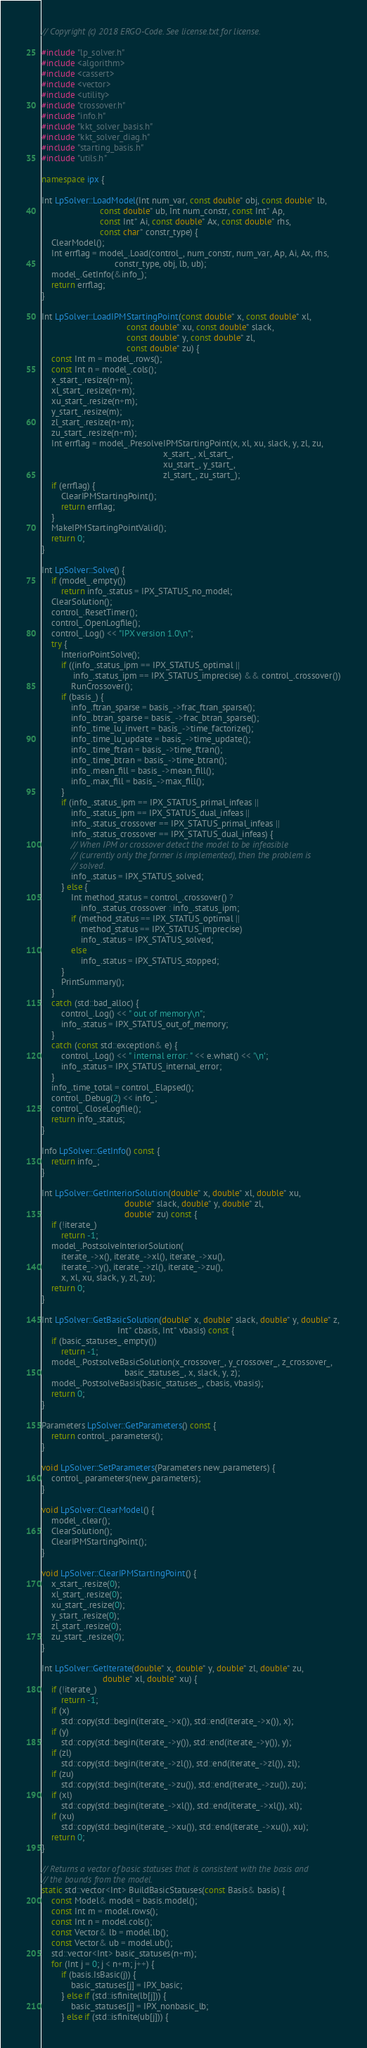<code> <loc_0><loc_0><loc_500><loc_500><_C++_>// Copyright (c) 2018 ERGO-Code. See license.txt for license.

#include "lp_solver.h"
#include <algorithm>
#include <cassert>
#include <vector>
#include <utility>
#include "crossover.h"
#include "info.h"
#include "kkt_solver_basis.h"
#include "kkt_solver_diag.h"
#include "starting_basis.h"
#include "utils.h"

namespace ipx {

Int LpSolver::LoadModel(Int num_var, const double* obj, const double* lb,
                        const double* ub, Int num_constr, const Int* Ap,
                        const Int* Ai, const double* Ax, const double* rhs,
                        const char* constr_type) {
    ClearModel();
    Int errflag = model_.Load(control_, num_constr, num_var, Ap, Ai, Ax, rhs,
                              constr_type, obj, lb, ub);
    model_.GetInfo(&info_);
    return errflag;
}

Int LpSolver::LoadIPMStartingPoint(const double* x, const double* xl,
                                   const double* xu, const double* slack,
                                   const double* y, const double* zl,
                                   const double* zu) {
    const Int m = model_.rows();
    const Int n = model_.cols();
    x_start_.resize(n+m);
    xl_start_.resize(n+m);
    xu_start_.resize(n+m);
    y_start_.resize(m);
    zl_start_.resize(n+m);
    zu_start_.resize(n+m);
    Int errflag = model_.PresolveIPMStartingPoint(x, xl, xu, slack, y, zl, zu,
                                                  x_start_, xl_start_,
                                                  xu_start_, y_start_,
                                                  zl_start_, zu_start_);
    if (errflag) {
        ClearIPMStartingPoint();
        return errflag;
    }
    MakeIPMStartingPointValid();
    return 0;
}

Int LpSolver::Solve() {
    if (model_.empty())
        return info_.status = IPX_STATUS_no_model;
    ClearSolution();
    control_.ResetTimer();
    control_.OpenLogfile();
    control_.Log() << "IPX version 1.0\n";
    try {
        InteriorPointSolve();
        if ((info_.status_ipm == IPX_STATUS_optimal ||
             info_.status_ipm == IPX_STATUS_imprecise) && control_.crossover())
            RunCrossover();
        if (basis_) {
            info_.ftran_sparse = basis_->frac_ftran_sparse();
            info_.btran_sparse = basis_->frac_btran_sparse();
            info_.time_lu_invert = basis_->time_factorize();
            info_.time_lu_update = basis_->time_update();
            info_.time_ftran = basis_->time_ftran();
            info_.time_btran = basis_->time_btran();
            info_.mean_fill = basis_->mean_fill();
            info_.max_fill = basis_->max_fill();
        }
        if (info_.status_ipm == IPX_STATUS_primal_infeas ||
            info_.status_ipm == IPX_STATUS_dual_infeas ||
            info_.status_crossover == IPX_STATUS_primal_infeas ||
            info_.status_crossover == IPX_STATUS_dual_infeas) {
            // When IPM or crossover detect the model to be infeasible
            // (currently only the former is implemented), then the problem is
            // solved.
            info_.status = IPX_STATUS_solved;
        } else {
            Int method_status = control_.crossover() ?
                info_.status_crossover : info_.status_ipm;
            if (method_status == IPX_STATUS_optimal ||
                method_status == IPX_STATUS_imprecise)
                info_.status = IPX_STATUS_solved;
            else
                info_.status = IPX_STATUS_stopped;
        }
        PrintSummary();
    }
    catch (std::bad_alloc) {
        control_.Log() << " out of memory\n";
        info_.status = IPX_STATUS_out_of_memory;
    }
    catch (const std::exception& e) {
        control_.Log() << " internal error: " << e.what() << '\n';
        info_.status = IPX_STATUS_internal_error;
    }
    info_.time_total = control_.Elapsed();
    control_.Debug(2) << info_;
    control_.CloseLogfile();
    return info_.status;
}

Info LpSolver::GetInfo() const {
    return info_;
}

Int LpSolver::GetInteriorSolution(double* x, double* xl, double* xu,
                                  double* slack, double* y, double* zl,
                                  double* zu) const {
    if (!iterate_)
        return -1;
    model_.PostsolveInteriorSolution(
        iterate_->x(), iterate_->xl(), iterate_->xu(),
        iterate_->y(), iterate_->zl(), iterate_->zu(),
        x, xl, xu, slack, y, zl, zu);
    return 0;
}

Int LpSolver::GetBasicSolution(double* x, double* slack, double* y, double* z,
                               Int* cbasis, Int* vbasis) const {
    if (basic_statuses_.empty())
        return -1;
    model_.PostsolveBasicSolution(x_crossover_, y_crossover_, z_crossover_,
                                  basic_statuses_, x, slack, y, z);
    model_.PostsolveBasis(basic_statuses_, cbasis, vbasis);
    return 0;
}

Parameters LpSolver::GetParameters() const {
    return control_.parameters();
}

void LpSolver::SetParameters(Parameters new_parameters) {
    control_.parameters(new_parameters);
}

void LpSolver::ClearModel() {
    model_.clear();
    ClearSolution();
    ClearIPMStartingPoint();
}

void LpSolver::ClearIPMStartingPoint() {
    x_start_.resize(0);
    xl_start_.resize(0);
    xu_start_.resize(0);
    y_start_.resize(0);
    zl_start_.resize(0);
    zu_start_.resize(0);
}

Int LpSolver::GetIterate(double* x, double* y, double* zl, double* zu,
                         double* xl, double* xu) {
    if (!iterate_)
        return -1;
    if (x)
        std::copy(std::begin(iterate_->x()), std::end(iterate_->x()), x);
    if (y)
        std::copy(std::begin(iterate_->y()), std::end(iterate_->y()), y);
    if (zl)
        std::copy(std::begin(iterate_->zl()), std::end(iterate_->zl()), zl);
    if (zu)
        std::copy(std::begin(iterate_->zu()), std::end(iterate_->zu()), zu);
    if (xl)
        std::copy(std::begin(iterate_->xl()), std::end(iterate_->xl()), xl);
    if (xu)
        std::copy(std::begin(iterate_->xu()), std::end(iterate_->xu()), xu);
    return 0;
}

// Returns a vector of basic statuses that is consistent with the basis and
// the bounds from the model.
static std::vector<Int> BuildBasicStatuses(const Basis& basis) {
    const Model& model = basis.model();
    const Int m = model.rows();
    const Int n = model.cols();
    const Vector& lb = model.lb();
    const Vector& ub = model.ub();
    std::vector<Int> basic_statuses(n+m);
    for (Int j = 0; j < n+m; j++) {
        if (basis.IsBasic(j)) {
            basic_statuses[j] = IPX_basic;
        } else if (std::isfinite(lb[j])) {
            basic_statuses[j] = IPX_nonbasic_lb;
        } else if (std::isfinite(ub[j])) {</code> 